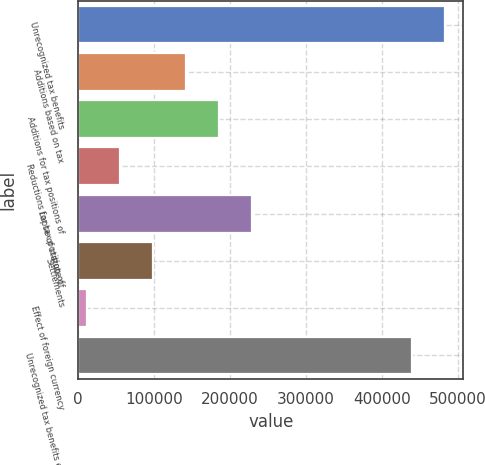Convert chart to OTSL. <chart><loc_0><loc_0><loc_500><loc_500><bar_chart><fcel>Unrecognized tax benefits<fcel>Additions based on tax<fcel>Additions for tax positions of<fcel>Reductions for tax position of<fcel>Lapse of statute of<fcel>Settlements<fcel>Effect of foreign currency<fcel>Unrecognized tax benefits end<nl><fcel>482855<fcel>142190<fcel>185719<fcel>55131.9<fcel>229248<fcel>98660.8<fcel>11603<fcel>439326<nl></chart> 